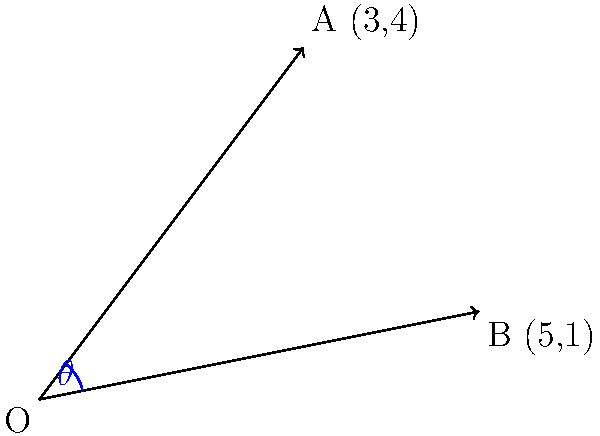In a performance of Stravinsky's "The Rite of Spring," the conductor's baton follows the path represented by vector $\vec{OA} = (3,4)$. For the subsequent performance of Beethoven's "Symphony No. 5," the baton's path is represented by vector $\vec{OB} = (5,1)$. What is the angle $\theta$ between these two vectors, representing the shift in conducting style between these contrasting pieces? To find the angle between two vectors, we can use the dot product formula:

$$\cos \theta = \frac{\vec{OA} \cdot \vec{OB}}{|\vec{OA}||\vec{OB}|}$$

Step 1: Calculate the dot product $\vec{OA} \cdot \vec{OB}$
$$\vec{OA} \cdot \vec{OB} = (3)(5) + (4)(1) = 15 + 4 = 19$$

Step 2: Calculate the magnitudes of the vectors
$$|\vec{OA}| = \sqrt{3^2 + 4^2} = \sqrt{9 + 16} = \sqrt{25} = 5$$
$$|\vec{OB}| = \sqrt{5^2 + 1^2} = \sqrt{25 + 1} = \sqrt{26}$$

Step 3: Apply the formula
$$\cos \theta = \frac{19}{5\sqrt{26}}$$

Step 4: Take the inverse cosine (arccos) of both sides
$$\theta = \arccos(\frac{19}{5\sqrt{26}})$$

Step 5: Calculate the result (in degrees)
$$\theta \approx 32.47°$$

This angle represents the dramatic shift from Stravinsky's revolutionary composition to Beethoven's classical masterpiece, demonstrating the versatility required in conducting these contrasting works.
Answer: $32.47°$ 